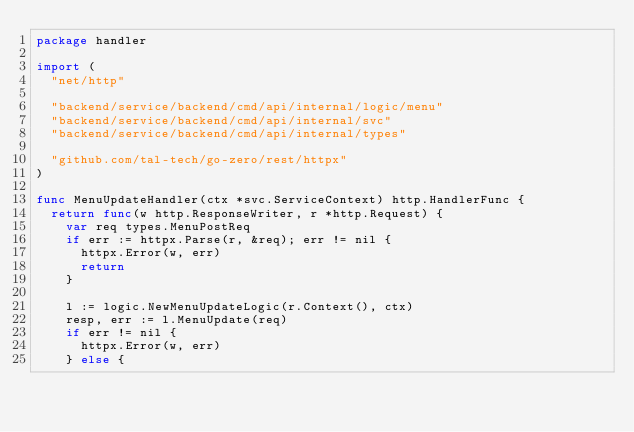Convert code to text. <code><loc_0><loc_0><loc_500><loc_500><_Go_>package handler

import (
	"net/http"

	"backend/service/backend/cmd/api/internal/logic/menu"
	"backend/service/backend/cmd/api/internal/svc"
	"backend/service/backend/cmd/api/internal/types"

	"github.com/tal-tech/go-zero/rest/httpx"
)

func MenuUpdateHandler(ctx *svc.ServiceContext) http.HandlerFunc {
	return func(w http.ResponseWriter, r *http.Request) {
		var req types.MenuPostReq
		if err := httpx.Parse(r, &req); err != nil {
			httpx.Error(w, err)
			return
		}

		l := logic.NewMenuUpdateLogic(r.Context(), ctx)
		resp, err := l.MenuUpdate(req)
		if err != nil {
			httpx.Error(w, err)
		} else {</code> 